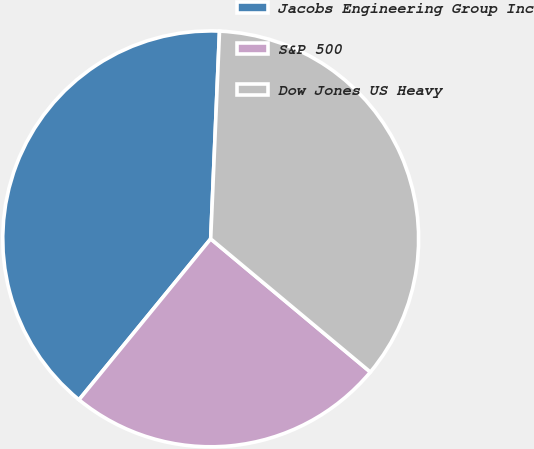<chart> <loc_0><loc_0><loc_500><loc_500><pie_chart><fcel>Jacobs Engineering Group Inc<fcel>S&P 500<fcel>Dow Jones US Heavy<nl><fcel>39.76%<fcel>24.85%<fcel>35.39%<nl></chart> 